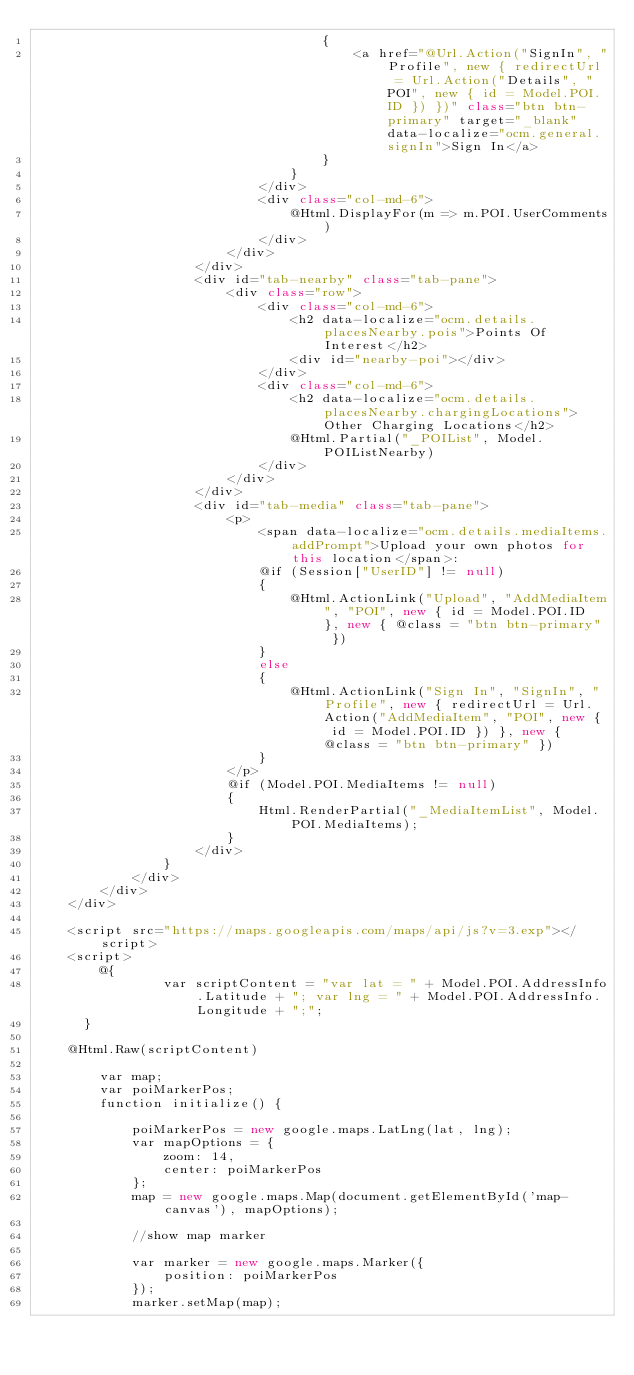Convert code to text. <code><loc_0><loc_0><loc_500><loc_500><_C#_>                                    {
                                        <a href="@Url.Action("SignIn", "Profile", new { redirectUrl = Url.Action("Details", "POI", new { id = Model.POI.ID }) })" class="btn btn-primary" target="_blank" data-localize="ocm.general.signIn">Sign In</a>
                                    }
                                }
                            </div>
                            <div class="col-md-6">
                                @Html.DisplayFor(m => m.POI.UserComments)
                            </div>
                        </div>
                    </div>
                    <div id="tab-nearby" class="tab-pane">
                        <div class="row">
                            <div class="col-md-6">
                                <h2 data-localize="ocm.details.placesNearby.pois">Points Of Interest</h2>
                                <div id="nearby-poi"></div>
                            </div>
                            <div class="col-md-6">
                                <h2 data-localize="ocm.details.placesNearby.chargingLocations">Other Charging Locations</h2>
                                @Html.Partial("_POIList", Model.POIListNearby)
                            </div>
                        </div>
                    </div>
                    <div id="tab-media" class="tab-pane">
                        <p>
                            <span data-localize="ocm.details.mediaItems.addPrompt">Upload your own photos for this location</span>:
                            @if (Session["UserID"] != null)
                            {
                                @Html.ActionLink("Upload", "AddMediaItem", "POI", new { id = Model.POI.ID }, new { @class = "btn btn-primary" })
                            }
                            else
                            {
                                @Html.ActionLink("Sign In", "SignIn", "Profile", new { redirectUrl = Url.Action("AddMediaItem", "POI", new { id = Model.POI.ID }) }, new { @class = "btn btn-primary" })
                            }
                        </p>
                        @if (Model.POI.MediaItems != null)
                        {
                            Html.RenderPartial("_MediaItemList", Model.POI.MediaItems);
                        }
                    </div>
                }
            </div>
        </div>
    </div>

    <script src="https://maps.googleapis.com/maps/api/js?v=3.exp"></script>
    <script>
        @{
                var scriptContent = "var lat = " + Model.POI.AddressInfo.Latitude + "; var lng = " + Model.POI.AddressInfo.Longitude + ";";
      }

    @Html.Raw(scriptContent)

        var map;
        var poiMarkerPos;
        function initialize() {

            poiMarkerPos = new google.maps.LatLng(lat, lng);
            var mapOptions = {
                zoom: 14,
                center: poiMarkerPos
            };
            map = new google.maps.Map(document.getElementById('map-canvas'), mapOptions);

            //show map marker

            var marker = new google.maps.Marker({
                position: poiMarkerPos
            });
            marker.setMap(map);</code> 